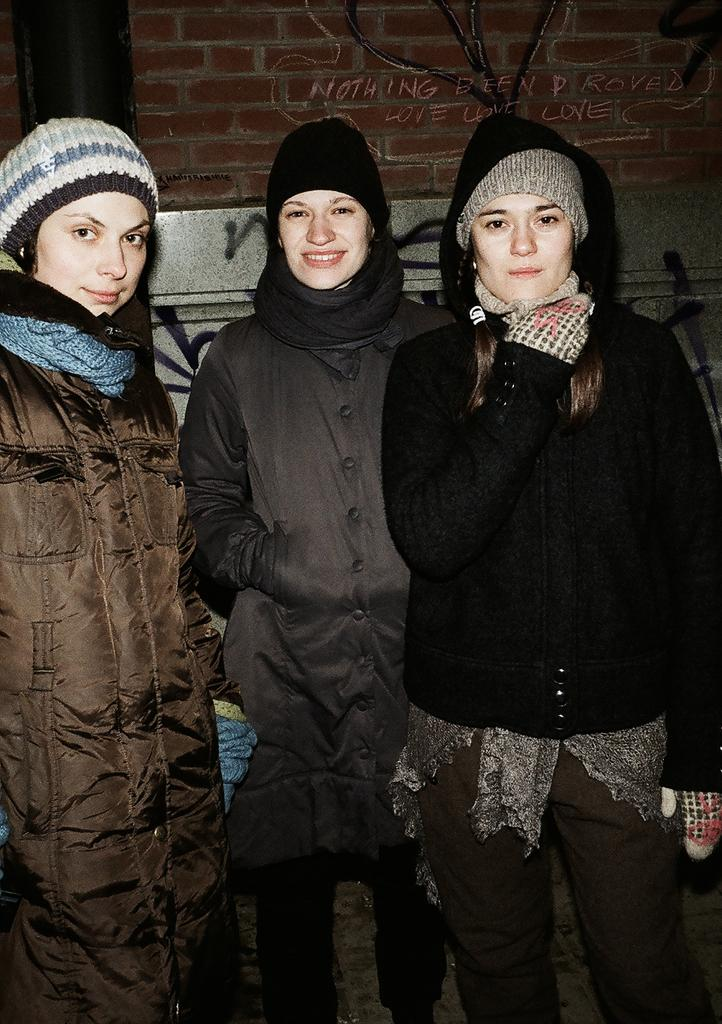How many people are in the image? There are three persons in the image. What are the persons wearing on their upper bodies? Each person is wearing a jacket. What are the persons wearing around their necks? Each person is wearing a scarf. What are the persons wearing on their heads? Each person is wearing a cap. Where are the persons standing in the image? The persons are standing on the floor. What is behind the persons in the image? There is a wall behind the persons. What type of representative is depicted in the image? There is no representative depicted in the image; it features three persons wearing jackets, scarves, and caps. Are there any slaves present in the image? There is no mention of slaves in the image, and it does not depict any such individuals. 